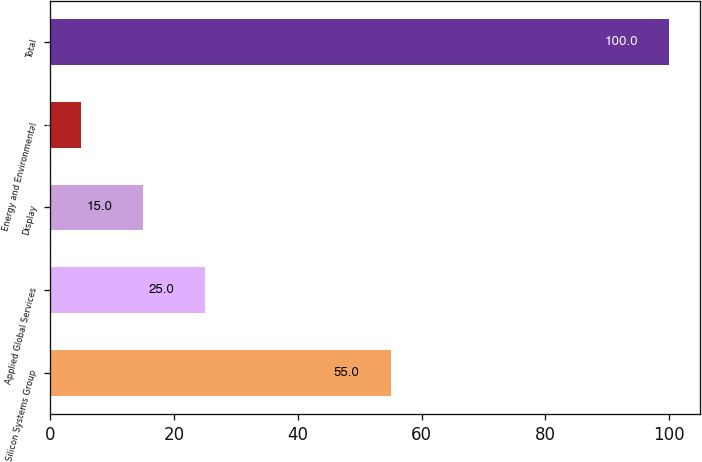Convert chart to OTSL. <chart><loc_0><loc_0><loc_500><loc_500><bar_chart><fcel>Silicon Systems Group<fcel>Applied Global Services<fcel>Display<fcel>Energy and Environmental<fcel>Total<nl><fcel>55<fcel>25<fcel>15<fcel>5<fcel>100<nl></chart> 